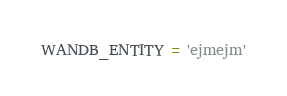Convert code to text. <code><loc_0><loc_0><loc_500><loc_500><_Python_>WANDB_ENTITY = 'ejmejm'</code> 